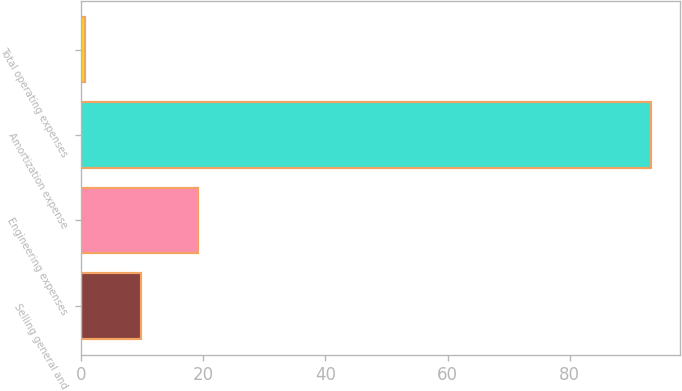<chart> <loc_0><loc_0><loc_500><loc_500><bar_chart><fcel>Selling general and<fcel>Engineering expenses<fcel>Amortization expense<fcel>Total operating expenses<nl><fcel>9.88<fcel>19.16<fcel>93.4<fcel>0.6<nl></chart> 